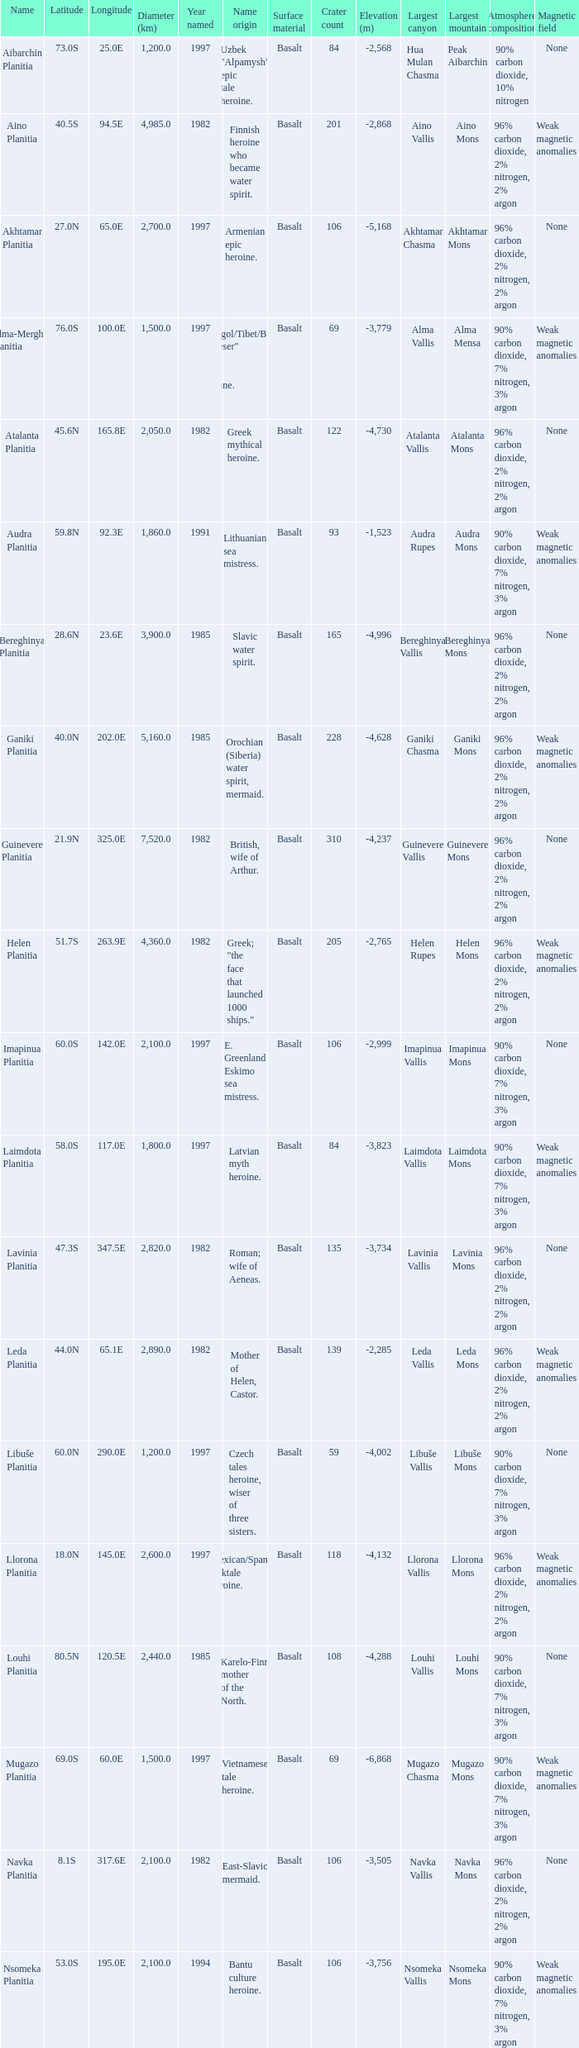What is the measurement (km) of the aspect at latitude 2 3000.0. Can you parse all the data within this table? {'header': ['Name', 'Latitude', 'Longitude', 'Diameter (km)', 'Year named', 'Name origin', 'Surface material', 'Crater count', 'Elevation (m)', 'Largest canyon', 'Largest mountain', 'Atmosphere composition', 'Magnetic field '], 'rows': [['Aibarchin Planitia', '73.0S', '25.0E', '1,200.0', '1997', 'Uzbek "Alpamysh" epic tale heroine.', 'Basalt', '84', '-2,568', 'Hua Mulan Chasma', 'Peak Aibarchin', '90% carbon dioxide, 10% nitrogen', 'None'], ['Aino Planitia', '40.5S', '94.5E', '4,985.0', '1982', 'Finnish heroine who became water spirit.', 'Basalt', '201', '-2,868', 'Aino Vallis', 'Aino Mons', '96% carbon dioxide, 2% nitrogen, 2% argon', 'Weak magnetic anomalies'], ['Akhtamar Planitia', '27.0N', '65.0E', '2,700.0', '1997', 'Armenian epic heroine.', 'Basalt', '106', '-5,168', 'Akhtamar Chasma', 'Akhtamar Mons', '96% carbon dioxide, 2% nitrogen, 2% argon', 'None'], ['Alma-Merghen Planitia', '76.0S', '100.0E', '1,500.0', '1997', 'Mongol/Tibet/Buryat "Gheser" epic tale heroine.', 'Basalt', '69', '-3,779', 'Alma Vallis', 'Alma Mensa', '90% carbon dioxide, 7% nitrogen, 3% argon', 'Weak magnetic anomalies'], ['Atalanta Planitia', '45.6N', '165.8E', '2,050.0', '1982', 'Greek mythical heroine.', 'Basalt', '122', '-4,730', 'Atalanta Vallis', 'Atalanta Mons', '96% carbon dioxide, 2% nitrogen, 2% argon', 'None'], ['Audra Planitia', '59.8N', '92.3E', '1,860.0', '1991', 'Lithuanian sea mistress.', 'Basalt', '93', '-1,523', 'Audra Rupes', 'Audra Mons', '90% carbon dioxide, 7% nitrogen, 3% argon', 'Weak magnetic anomalies'], ['Bereghinya Planitia', '28.6N', '23.6E', '3,900.0', '1985', 'Slavic water spirit.', 'Basalt', '165', '-4,996', 'Bereghinya Vallis', 'Bereghinya Mons', '96% carbon dioxide, 2% nitrogen, 2% argon', 'None'], ['Ganiki Planitia', '40.0N', '202.0E', '5,160.0', '1985', 'Orochian (Siberia) water spirit, mermaid.', 'Basalt', '228', '-4,628', 'Ganiki Chasma', 'Ganiki Mons', '96% carbon dioxide, 2% nitrogen, 2% argon', 'Weak magnetic anomalies'], ['Guinevere Planitia', '21.9N', '325.0E', '7,520.0', '1982', 'British, wife of Arthur.', 'Basalt', '310', '-4,237', 'Guinevere Vallis', 'Guinevere Mons', '96% carbon dioxide, 2% nitrogen, 2% argon', 'None'], ['Helen Planitia', '51.7S', '263.9E', '4,360.0', '1982', 'Greek; "the face that launched 1000 ships."', 'Basalt', '205', '-2,765', 'Helen Rupes', 'Helen Mons', '96% carbon dioxide, 2% nitrogen, 2% argon', 'Weak magnetic anomalies'], ['Imapinua Planitia', '60.0S', '142.0E', '2,100.0', '1997', 'E. Greenland Eskimo sea mistress.', 'Basalt', '106', '-2,999', 'Imapinua Vallis', 'Imapinua Mons', '90% carbon dioxide, 7% nitrogen, 3% argon', 'None'], ['Laimdota Planitia', '58.0S', '117.0E', '1,800.0', '1997', 'Latvian myth heroine.', 'Basalt', '84', '-3,823', 'Laimdota Vallis', 'Laimdota Mons', '90% carbon dioxide, 7% nitrogen, 3% argon', 'Weak magnetic anomalies'], ['Lavinia Planitia', '47.3S', '347.5E', '2,820.0', '1982', 'Roman; wife of Aeneas.', 'Basalt', '135', '-3,734', 'Lavinia Vallis', 'Lavinia Mons', '96% carbon dioxide, 2% nitrogen, 2% argon', 'None'], ['Leda Planitia', '44.0N', '65.1E', '2,890.0', '1982', 'Mother of Helen, Castor.', 'Basalt', '139', '-2,285', 'Leda Vallis', 'Leda Mons', '96% carbon dioxide, 2% nitrogen, 2% argon', 'Weak magnetic anomalies'], ['Libuše Planitia', '60.0N', '290.0E', '1,200.0', '1997', 'Czech tales heroine, wiser of three sisters.', 'Basalt', '59', '-4,002', 'Libuše Vallis', 'Libuše Mons', '90% carbon dioxide, 7% nitrogen, 3% argon', 'None'], ['Llorona Planitia', '18.0N', '145.0E', '2,600.0', '1997', 'Mexican/Spanish folktale heroine.', 'Basalt', '118', '-4,132', 'Llorona Vallis', 'Llorona Mons', '96% carbon dioxide, 2% nitrogen, 2% argon', 'Weak magnetic anomalies'], ['Louhi Planitia', '80.5N', '120.5E', '2,440.0', '1985', 'Karelo-Finn mother of the North.', 'Basalt', '108', '-4,288', 'Louhi Vallis', 'Louhi Mons', '90% carbon dioxide, 7% nitrogen, 3% argon', 'None'], ['Mugazo Planitia', '69.0S', '60.0E', '1,500.0', '1997', 'Vietnamese tale heroine.', 'Basalt', '69', '-6,868', 'Mugazo Chasma', 'Mugazo Mons', '90% carbon dioxide, 7% nitrogen, 3% argon', 'Weak magnetic anomalies'], ['Navka Planitia', '8.1S', '317.6E', '2,100.0', '1982', 'East-Slavic mermaid.', 'Basalt', '106', '-3,505', 'Navka Vallis', 'Navka Mons', '96% carbon dioxide, 2% nitrogen, 2% argon', 'None'], ['Nsomeka Planitia', '53.0S', '195.0E', '2,100.0', '1994', 'Bantu culture heroine.', 'Basalt', '106', '-3,756', 'Nsomeka Vallis', 'Nsomeka Mons', '90% carbon dioxide, 7% nitrogen, 3% argon', 'Weak magnetic anomalies'], ['Rusalka Planitia', '9.8N', '170.1E', '3,655.0', '1982', 'Russian mermaid.', 'Basalt', '155', '-4,041', 'Rusalka Vallis', 'Rusalka Mons', '96% carbon dioxide, 2% nitrogen, 2% argon', 'None'], ['Sedna Planitia', '42.7N', '340.7E', '3,570.0', '1982', 'Eskimo; her fingers became seals and whales.', 'Basalt', '172', '-3,109', 'Sedna Vallis', 'Sedna Mons', '96% carbon dioxide, 2% nitrogen, 2% argon', 'Weak magnetic anomalies'], ['Tahmina Planitia', '23.0S', '80.0E', '3,000.0', '1997', 'Iranian epic heroine, wife of knight Rustam.', 'Basalt', '139', '-5,634', 'Tahmina Vallis', 'Tahmina Mons', '90% carbon dioxide, 7% nitrogen, 3% argon', 'None'], ['Tilli-Hanum Planitia', '54.0N', '120.0E', '2,300.0', '1997', 'Azeri "Ker-ogly" epic tale heroine.', 'Basalt', '108', '-3,005', 'Tilli-Hanum Vallis', 'Tilli-Hanum Mons', '90% carbon dioxide, 7% nitrogen, 3% argon', 'Weak magnetic anomalies'], ['Tinatin Planitia', '15.0S', '15.0E', '0.0', '1994', 'Georgian epic heroine.', 'Basalt', '6', '-2,866', 'Tinatin Vallis', 'Tinatin Mons', '90% carbon dioxide, 7% nitrogen, 3% argon', 'None'], ['Undine Planitia', '13.0N', '303.0E', '2,800.0', '1997', 'Lithuanian water nymph, mermaid.', 'Basalt', '135', '-3,552', 'Undine Vallis', 'Undine Mons', '96% carbon dioxide, 2% nitrogen, 2% argon', 'Weak magnetic anomalies'], ['Vellamo Planitia', '45.4N', '149.1E', '2,155.0', '1985', 'Karelo-Finn mermaid.', 'Basalt', '106', '-4,189', 'Vellamo Vallis', 'Vellamo Mons', '90% carbon dioxide, 7% nitrogen, 3% argon', 'None']]} 